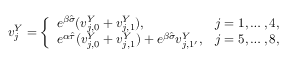<formula> <loc_0><loc_0><loc_500><loc_500>\begin{array} { r } { v _ { j } ^ { Y } = \left \{ \begin{array} { l l } { e ^ { \beta \hat { \sigma } } ( v _ { j , 0 } ^ { Y } + v _ { j , 1 } ^ { Y } ) , } & { j = 1 , \dots , 4 , } \\ { e ^ { \alpha \hat { \tau } } ( v _ { j , 0 } ^ { Y } + v _ { j , 1 } ^ { Y } ) + e ^ { \beta \hat { \sigma } } v _ { j , 1 ^ { \prime } } ^ { Y } , } & { j = 5 , \dots , 8 , } \end{array} } \end{array}</formula> 